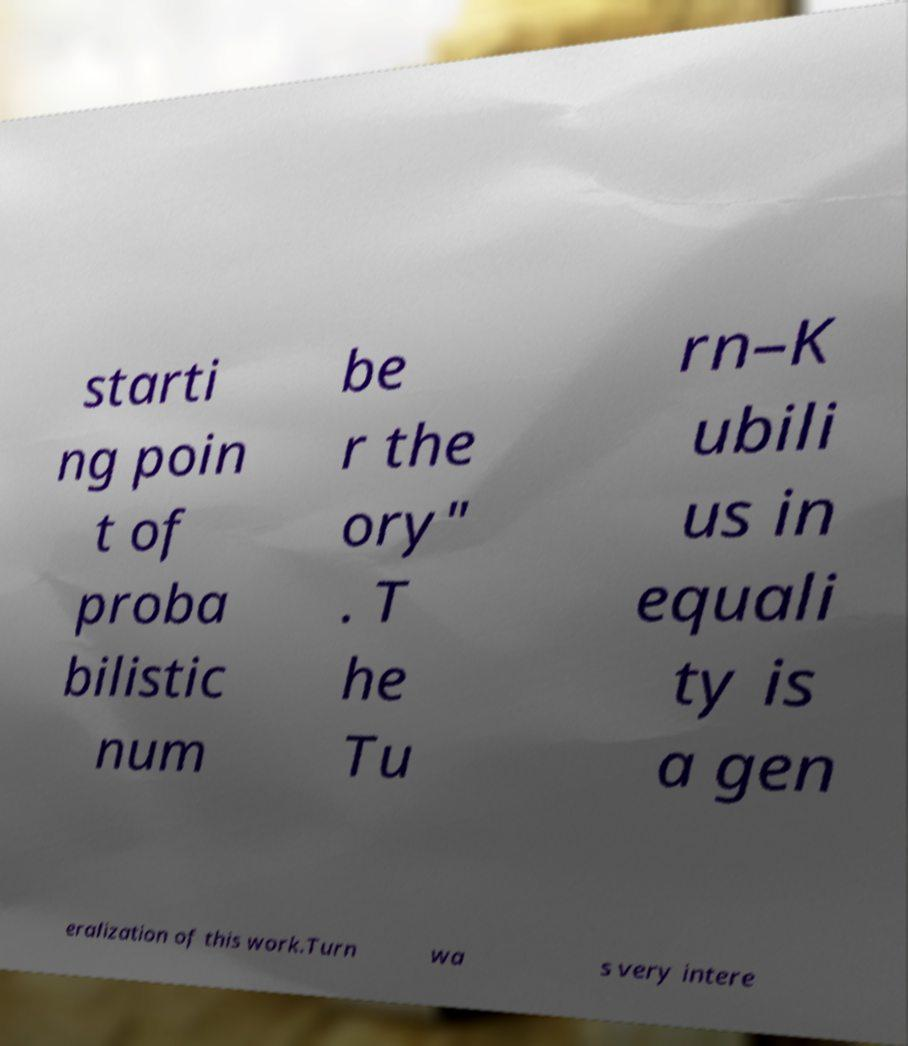For documentation purposes, I need the text within this image transcribed. Could you provide that? starti ng poin t of proba bilistic num be r the ory" . T he Tu rn–K ubili us in equali ty is a gen eralization of this work.Turn wa s very intere 